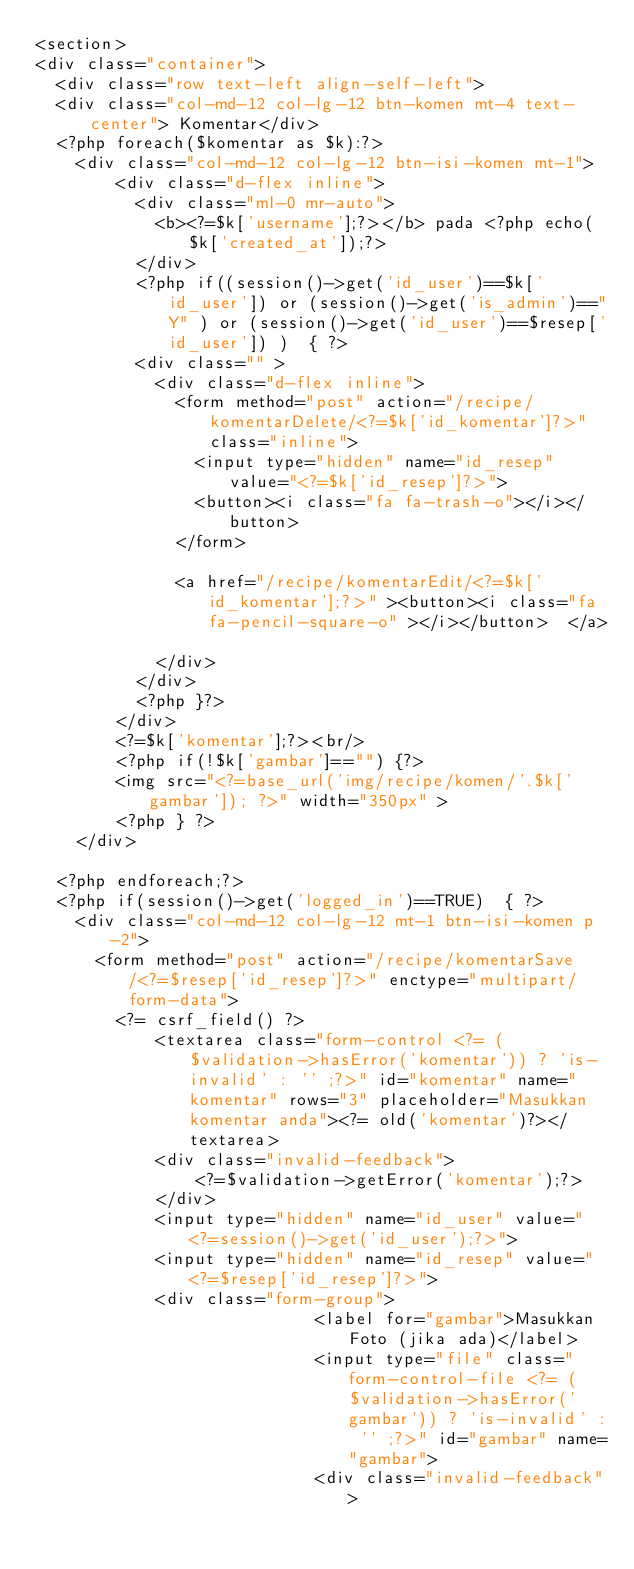Convert code to text. <code><loc_0><loc_0><loc_500><loc_500><_PHP_><section>
<div class="container">
  <div class="row text-left align-self-left">
  <div class="col-md-12 col-lg-12 btn-komen mt-4 text-center"> Komentar</div>
  <?php foreach($komentar as $k):?>
    <div class="col-md-12 col-lg-12 btn-isi-komen mt-1">
        <div class="d-flex inline">
          <div class="ml-0 mr-auto">
            <b><?=$k['username'];?></b> pada <?php echo($k['created_at']);?>
          </div>
          <?php if((session()->get('id_user')==$k['id_user']) or (session()->get('is_admin')=="Y" ) or (session()->get('id_user')==$resep['id_user']) )  { ?>
          <div class="" >
            <div class="d-flex inline">
              <form method="post" action="/recipe/komentarDelete/<?=$k['id_komentar']?>" class="inline">
                <input type="hidden" name="id_resep" value="<?=$k['id_resep']?>">
                <button><i class="fa fa-trash-o"></i></button>      
              </form>
              
              <a href="/recipe/komentarEdit/<?=$k['id_komentar'];?>" ><button><i class="fa fa-pencil-square-o" ></i></button>  </a>
              
            </div>
          </div>
          <?php }?>
        </div>    
        <?=$k['komentar'];?><br/>
        <?php if(!$k['gambar']=="") {?>
        <img src="<?=base_url('img/recipe/komen/'.$k['gambar']); ?>" width="350px" >
        <?php } ?>
    </div>

  <?php endforeach;?>
  <?php if(session()->get('logged_in')==TRUE)  { ?>
    <div class="col-md-12 col-lg-12 mt-1 btn-isi-komen p-2">
      <form method="post" action="/recipe/komentarSave/<?=$resep['id_resep']?>" enctype="multipart/form-data">
        <?= csrf_field() ?>
            <textarea class="form-control <?= ($validation->hasError('komentar')) ? 'is-invalid' : '' ;?>" id="komentar" name="komentar" rows="3" placeholder="Masukkan komentar anda"><?= old('komentar')?></textarea>
            <div class="invalid-feedback">
                <?=$validation->getError('komentar');?>
            </div>
            <input type="hidden" name="id_user" value="<?=session()->get('id_user');?>">
            <input type="hidden" name="id_resep" value="<?=$resep['id_resep']?>">
            <div class="form-group">
                            <label for="gambar">Masukkan Foto (jika ada)</label>
                            <input type="file" class="form-control-file <?= ($validation->hasError('gambar')) ? 'is-invalid' : '' ;?>" id="gambar" name="gambar">
                            <div class="invalid-feedback"></code> 